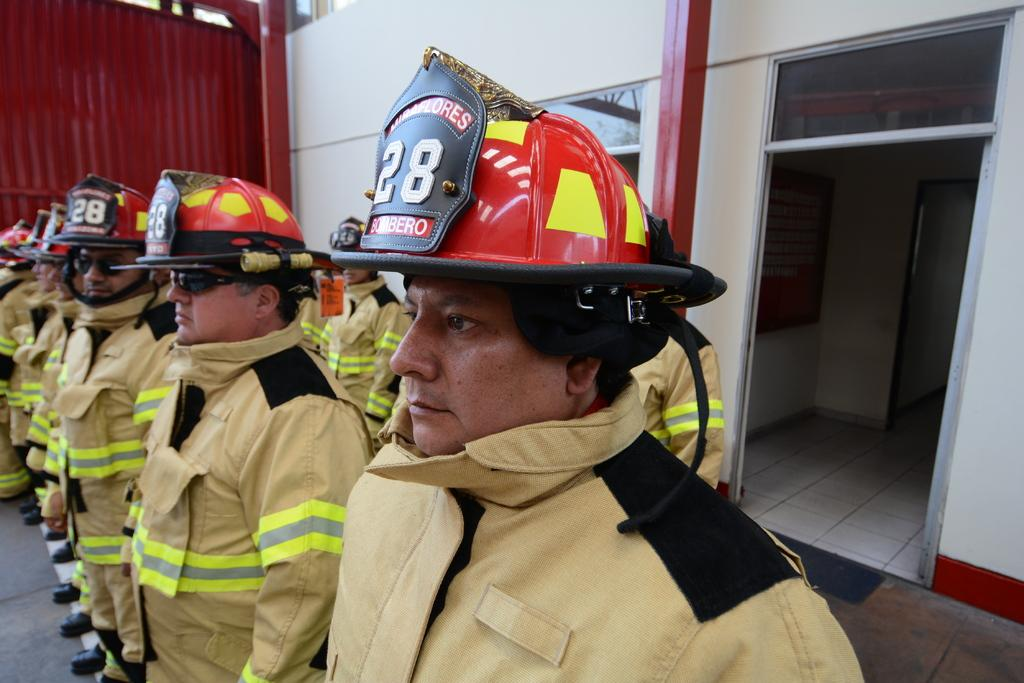What can be seen in the foreground of the image? There are men standing in the foreground area of the image. What are the men wearing on their heads? The men are wearing helmets. What type of clothing are the men wearing? The men are wearing uniforms. What type of eyewear are the men wearing? The men are wearing glasses. What can be seen in the background of the image? There is a door, windows, and metal sheets in the background of the image. How are the men sorting the pencils in the image? There are no pencils present in the image, so the men cannot be sorting them. 